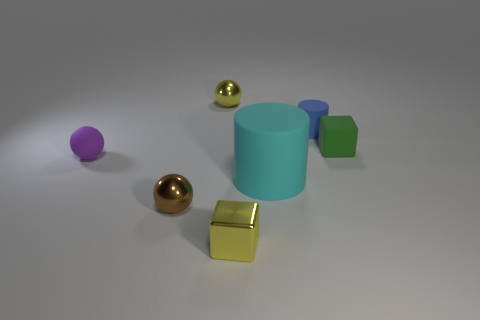Add 2 large purple cylinders. How many objects exist? 9 Subtract all balls. How many objects are left? 4 Subtract 0 green balls. How many objects are left? 7 Subtract all small green rubber objects. Subtract all tiny cylinders. How many objects are left? 5 Add 2 metal balls. How many metal balls are left? 4 Add 6 large purple metal blocks. How many large purple metal blocks exist? 6 